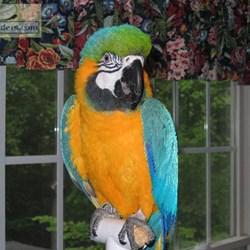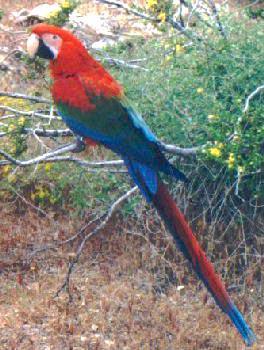The first image is the image on the left, the second image is the image on the right. Given the left and right images, does the statement "In one image, a person is standing in front of a roofed and screened cage area with three different colored parrots perched them." hold true? Answer yes or no. No. The first image is the image on the left, the second image is the image on the right. Considering the images on both sides, is "At least one image shows a person with three parrots perched somewhere on their body." valid? Answer yes or no. No. 